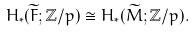Convert formula to latex. <formula><loc_0><loc_0><loc_500><loc_500>H _ { * } ( \widetilde { F } ; \mathbb { Z } / p ) \cong H _ { * } ( \widetilde { M } ; \mathbb { Z } / p ) .</formula> 